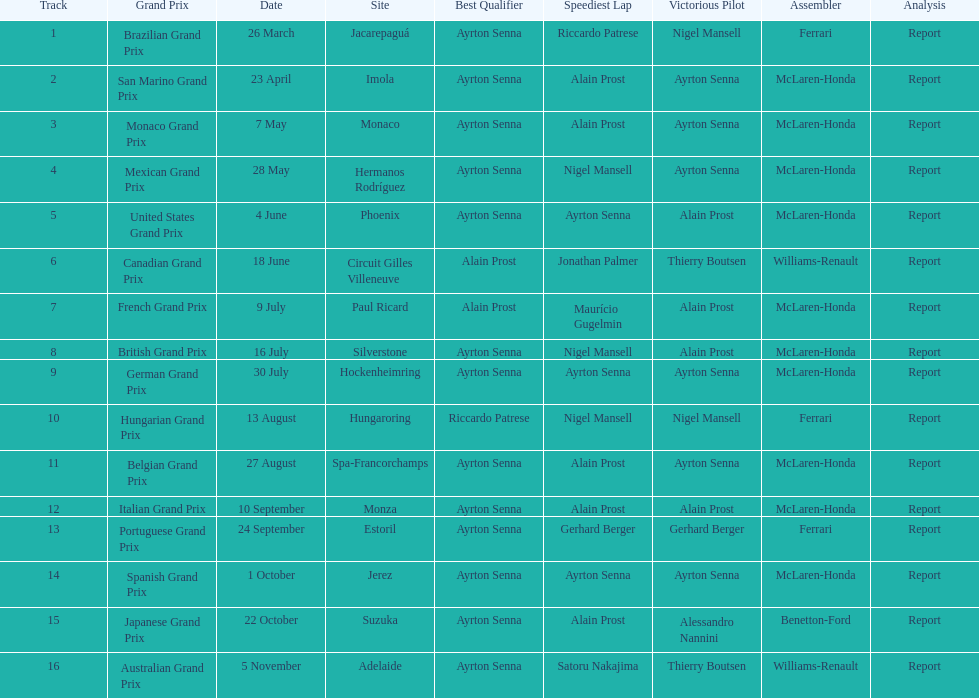How many did alain prost have the fastest lap? 5. 